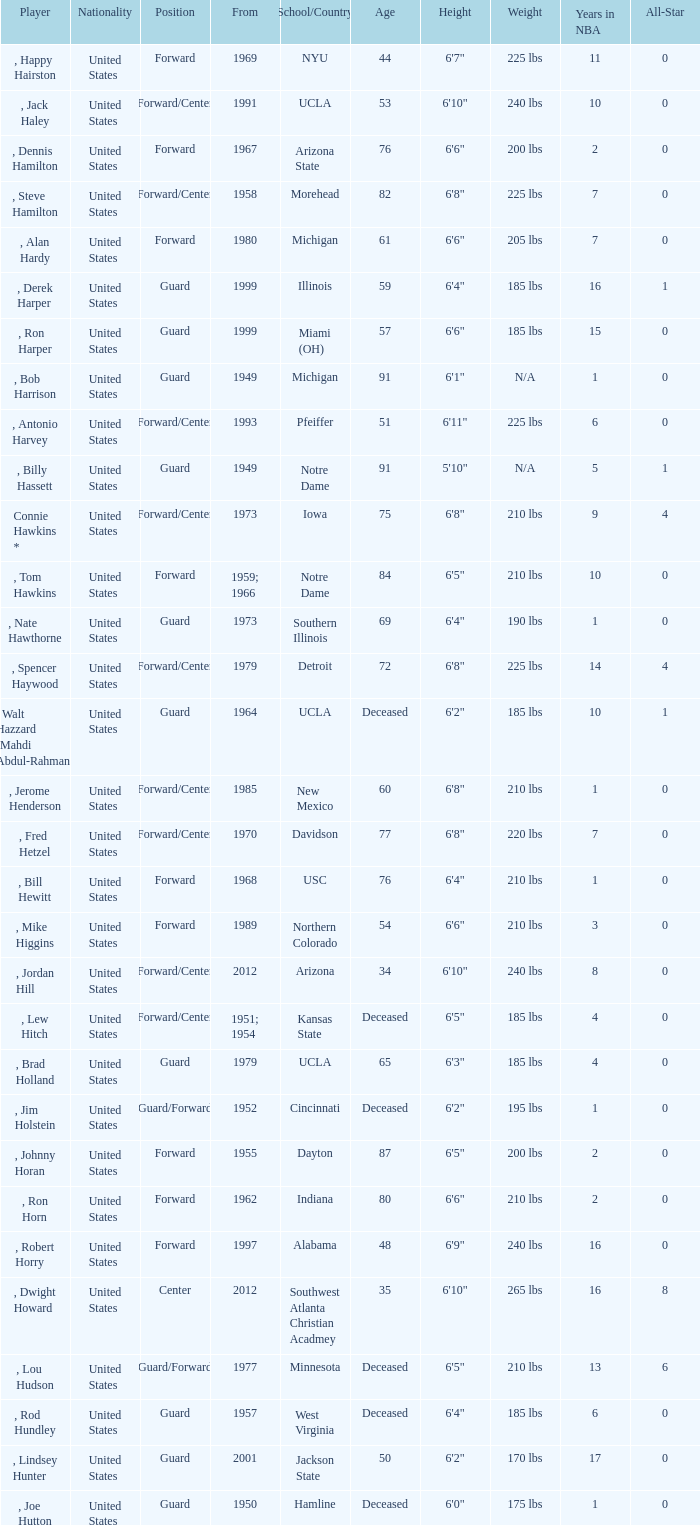What position was for Arizona State? Forward. 